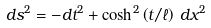Convert formula to latex. <formula><loc_0><loc_0><loc_500><loc_500>d s ^ { 2 } = - d t ^ { 2 } + \cosh ^ { 2 } \left ( t / \ell \right ) \, d x ^ { 2 }</formula> 